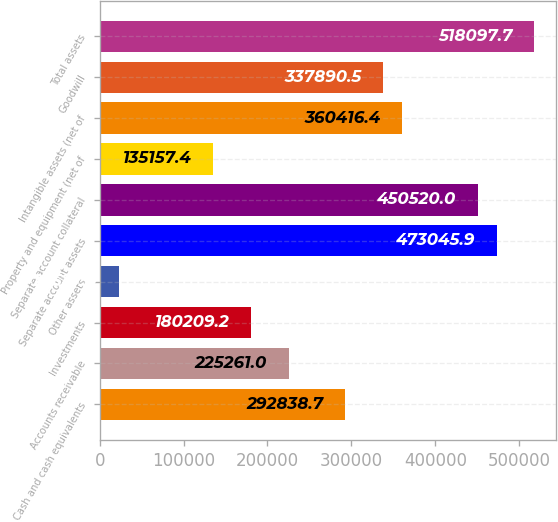<chart> <loc_0><loc_0><loc_500><loc_500><bar_chart><fcel>Cash and cash equivalents<fcel>Accounts receivable<fcel>Investments<fcel>Other assets<fcel>Separate account assets<fcel>Separate account collateral<fcel>Property and equipment (net of<fcel>Intangible assets (net of<fcel>Goodwill<fcel>Total assets<nl><fcel>292839<fcel>225261<fcel>180209<fcel>22527.9<fcel>473046<fcel>450520<fcel>135157<fcel>360416<fcel>337890<fcel>518098<nl></chart> 